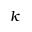<formula> <loc_0><loc_0><loc_500><loc_500>k</formula> 